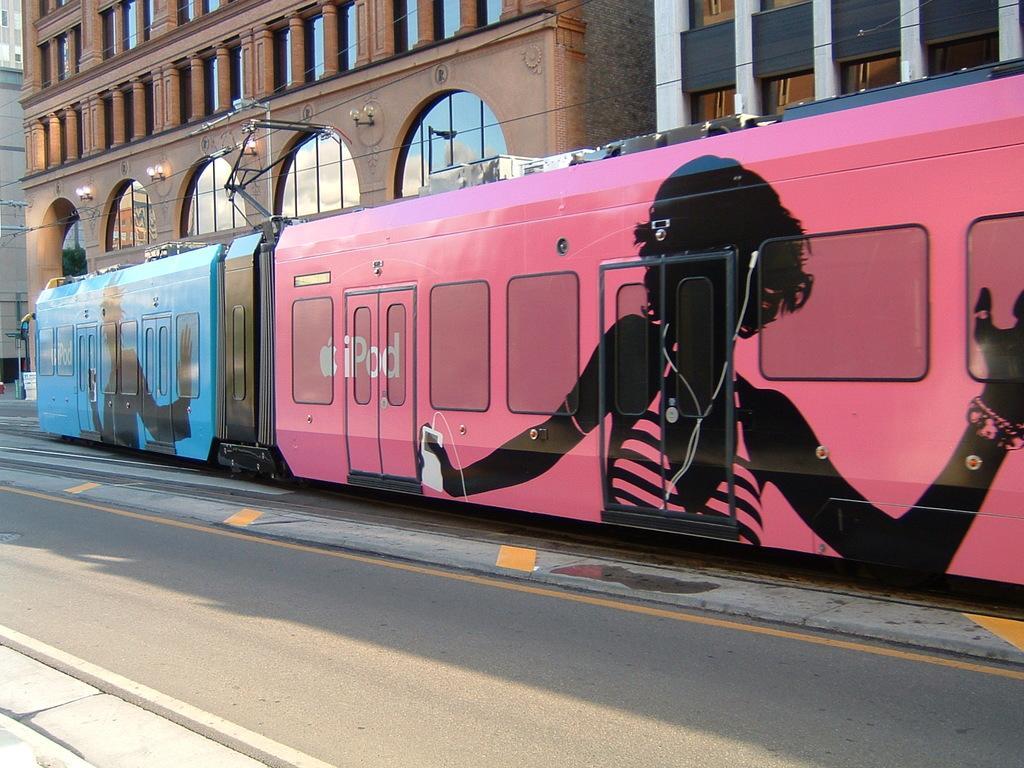Could you give a brief overview of what you see in this image? In this image there are buildings, in front of the buildings there is a train on the track, above the train there is metal rods connected to electrical cables, beside the train there is a road. 